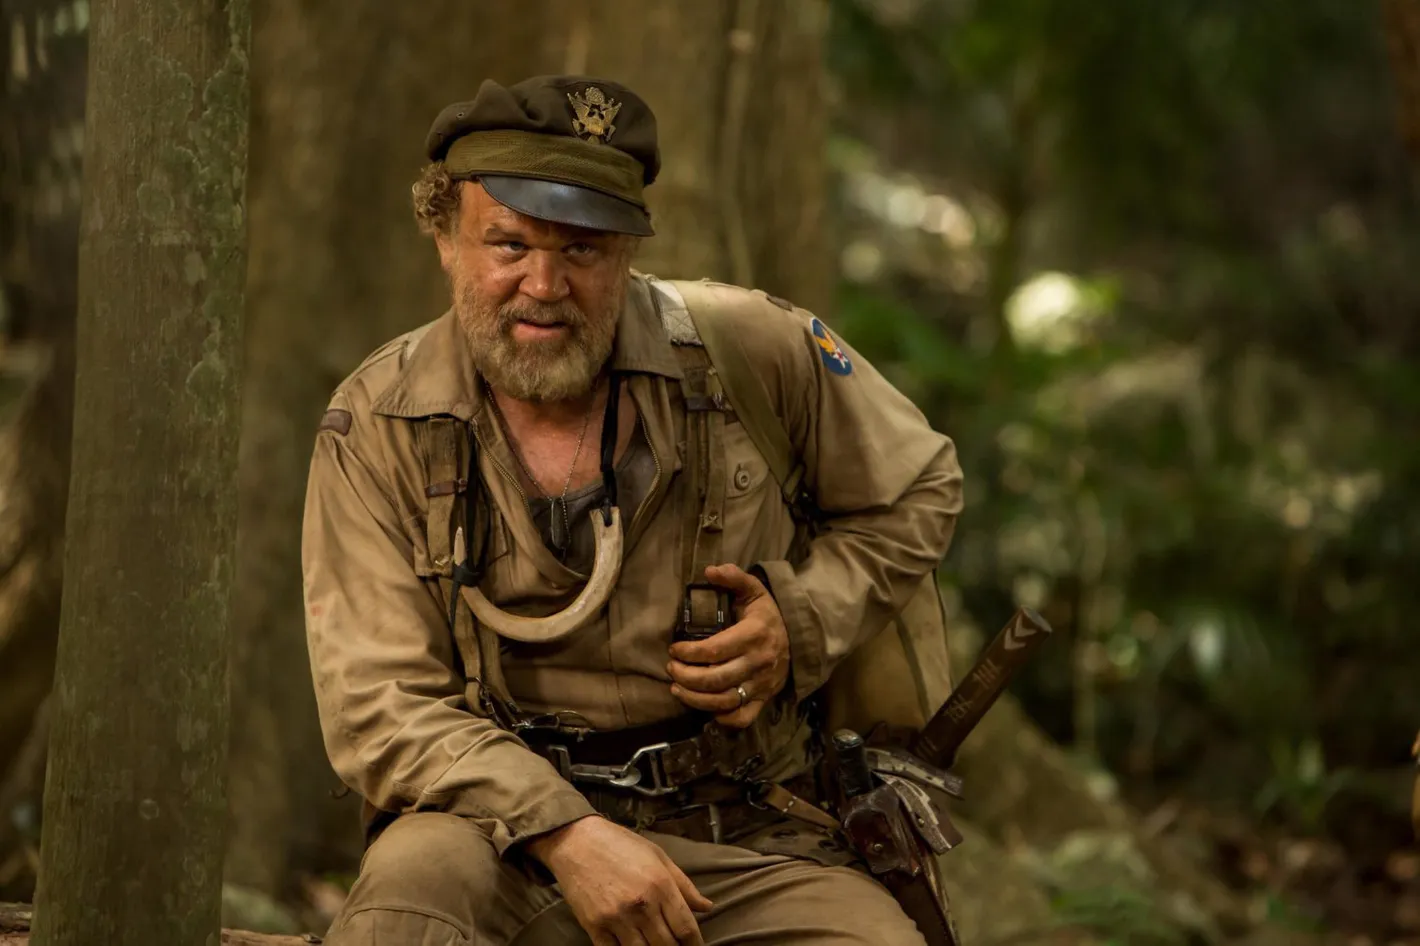Write a detailed description of the given image. In the heart of a dense forest, a seasoned actor portraying a rugged character reminiscent of Colonel Kurtz from the movie 'Kong: Skull Island' is captured in a moment of intense introspection. Seated on an old tree stump, he wears a worn khaki uniform that matches the earthy tones of the jungle around him. A well-worn hat sits atop his head, offering some shade from the dappled sunlight filtering through the canopy. He grips a weathered machete in one hand, held ready for any lurking threats. His weathered face, marked by a deep seriousness and years of experience, shows a man profoundly absorbed in his thoughts, surrounded by the mystery and danger of the untamed wilderness. 